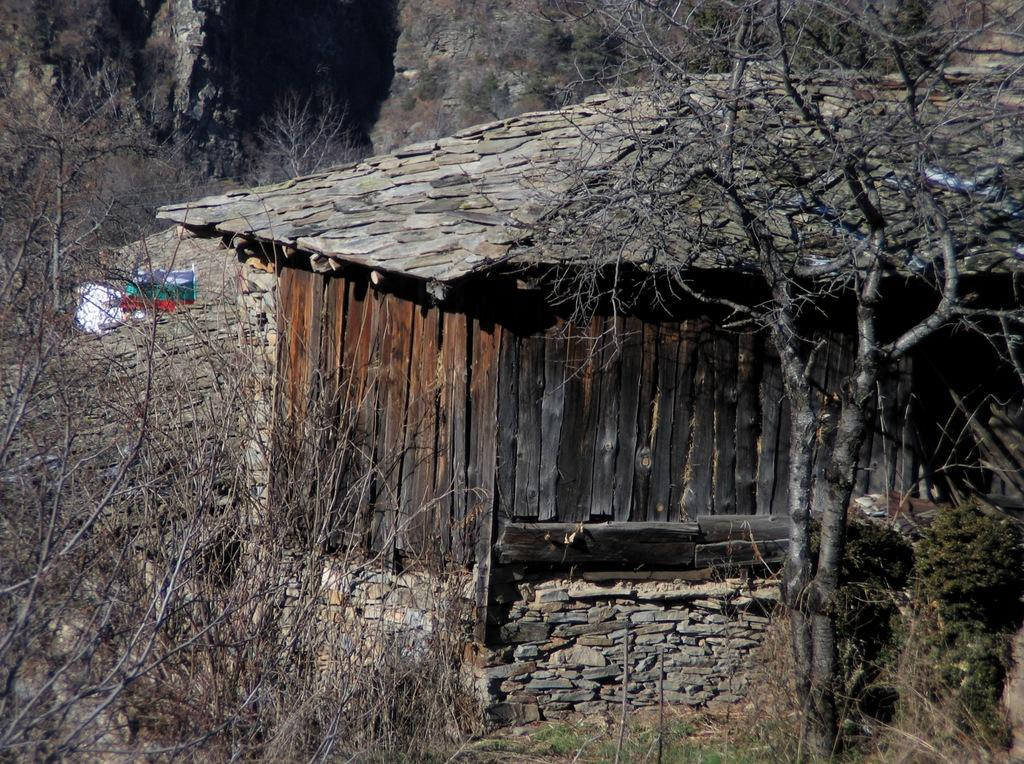What type of vegetation is visible in the front of the image? There are dry trees in the front of the image. What structure is located in the center of the image? There is a hut in the center of the image. What type of vegetation is visible in the background of the image? There are dry trees in the background of the image. How many legs can be seen on the dry trees in the image? Dry trees do not have legs; they are plants with roots and branches. Can you tell me how the dry trees are swimming in the image? Dry trees cannot swim, as they are stationary plants. 